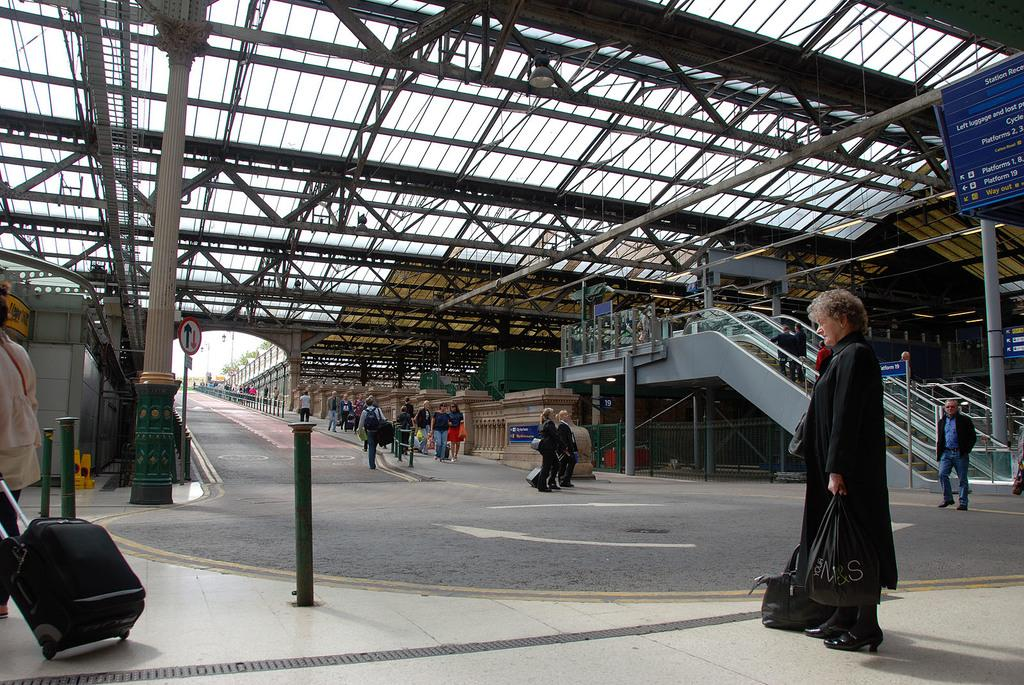What can be seen on both sides of the road in the image? There are groups of people standing on both sides of the road. What is present in the background of the image? There is an escalator in the background. What type of wall can be seen in the image? There is no wall present in the image. What answer is being given by the head in the image? There is no head or answer present in the image. 